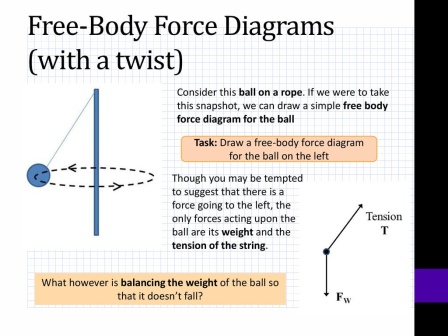Can you describe the educational value of the depicted slide? The slide serves significant educational value by clearly illustrating the concept of free-body diagrams through an engaging example. By presenting a practical scenario of a swinging ball, it contextualizes theoretical notions of forces, tension, and weight. This visual and instructional approach helps students grasp how individual forces interact within a system, enhancing their problem-solving skills and conceptual understanding. The accompanying task at the bottom reinforces active learning, prompting learners to apply what they've observed by constructing their own diagrams, thus deepening their engagement and retention of the topic. How could this slide be enhanced for even deeper understanding? To deepen comprehension, the slide could integrate interactive elements such as animations showing the ball’s motion over time, and how the forces of tension and weight dynamically change. Including a step-by-step guide on constructing free-body diagrams, and highlighting common misconceptions or errors, could further benefit learners. Additionally, offering varying difficulty levels in tasks, real-world applications, and perhaps integrating augmented reality (AR) features to allow hands-on virtual experiments would make the concepts more tangible and exciting, reinforcing the learning experience through multi-sensory engagement.  What if an additional mysterious force was acting on the ball? If a mysterious force were acting on the ball, it would introduce an intriguing twist to the current scenario. This force could, for instance, act laterally, perpendicular to both the tension in the rope and the gravitational force. An analysis of this situation would involve identifying the direction and magnitude of this new force and observing how it affects the ball’s trajectory. Such a scenario would serve as an excellent advanced problem for students, challenging them to think critically about how multiple forces combine to influence motion and leading to rich discussions and explorations of vector addition, equilibrium, and resultant forces in dynamic systems. 